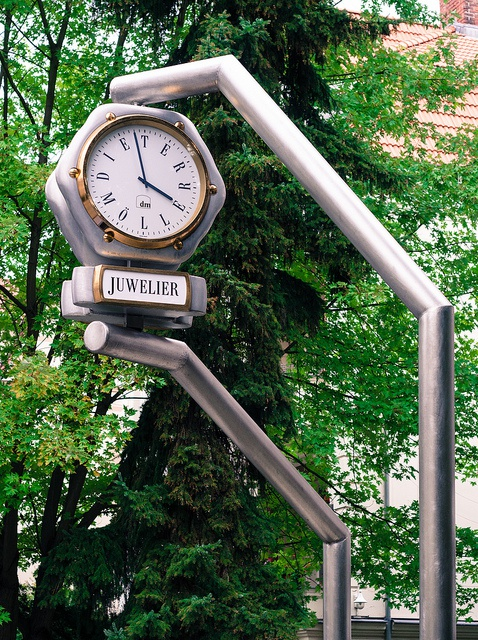Describe the objects in this image and their specific colors. I can see a clock in darkgreen, lavender, darkgray, gray, and black tones in this image. 